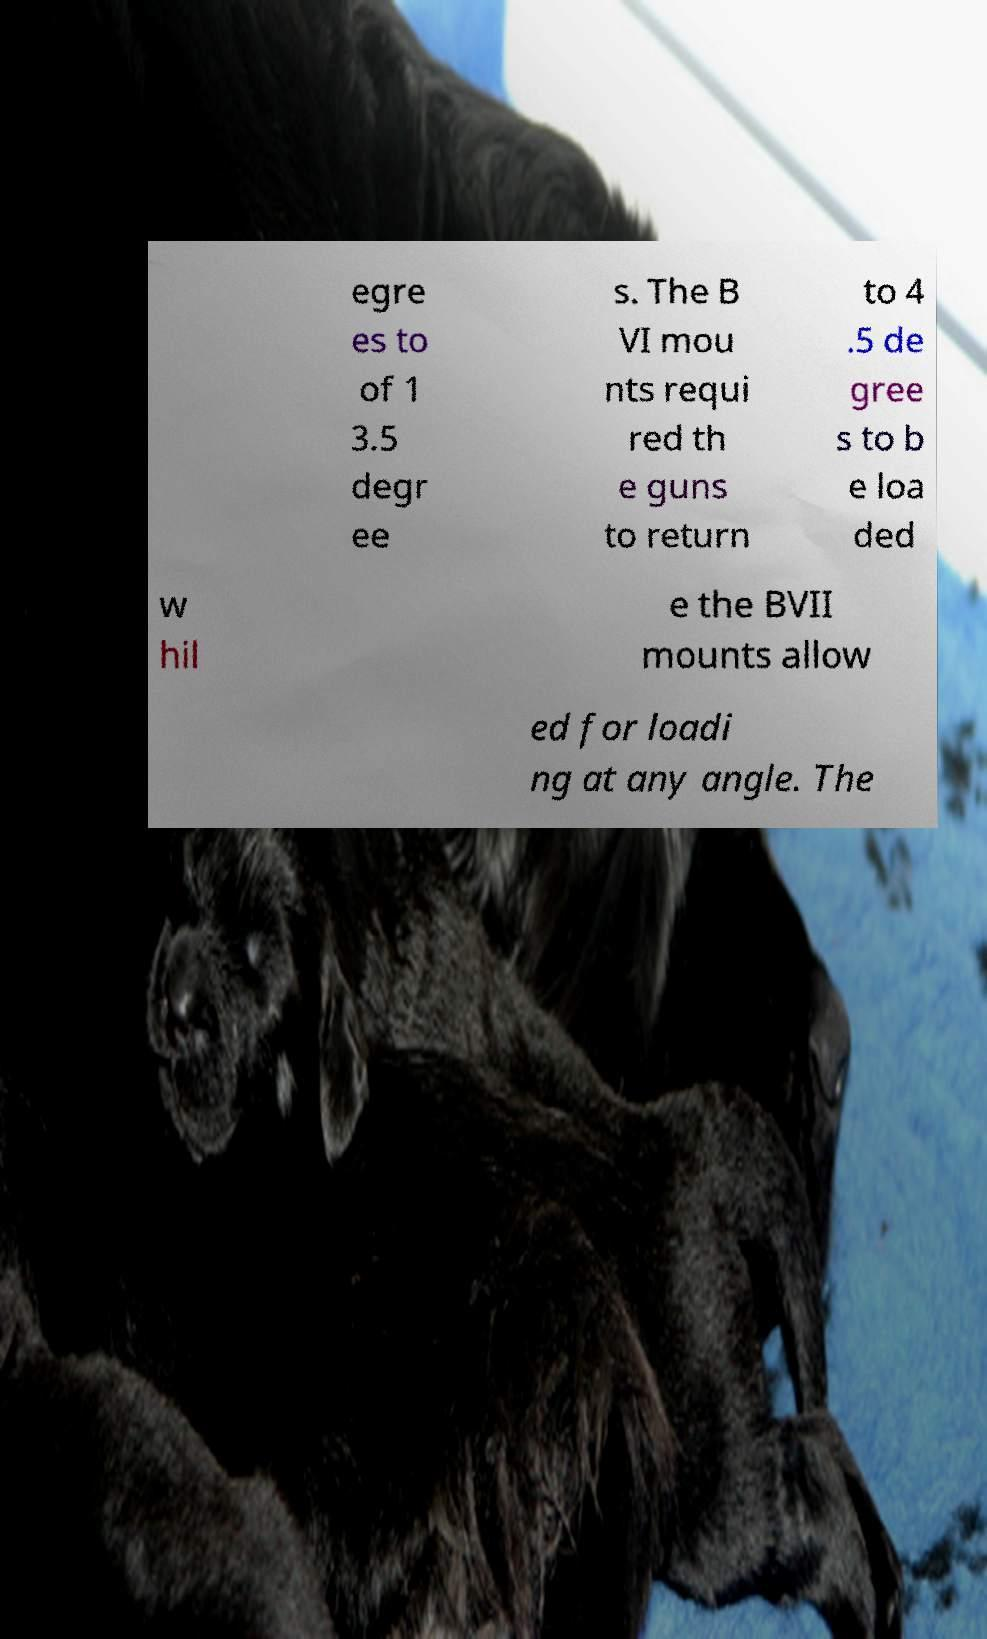What messages or text are displayed in this image? I need them in a readable, typed format. egre es to of 1 3.5 degr ee s. The B VI mou nts requi red th e guns to return to 4 .5 de gree s to b e loa ded w hil e the BVII mounts allow ed for loadi ng at any angle. The 